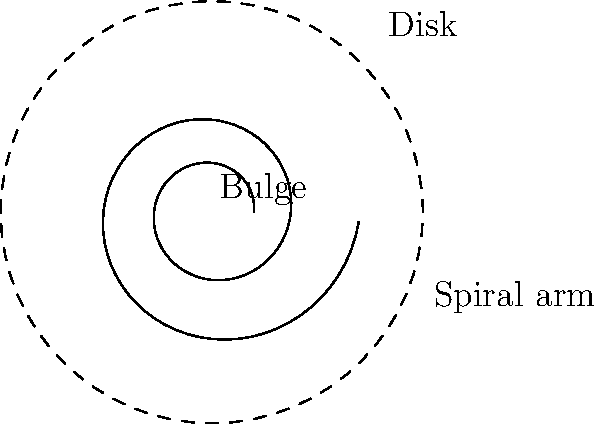As a web developer familiar with creating interactive visualizations, you're tasked with building a dynamic model of a spiral galaxy. Which structural component of the galaxy would you represent using SVG's `<circle>` element, and how does it relate to the galaxy's overall structure? Let's break down the structure of a spiral galaxy and how it relates to web development concepts:

1. Spiral galaxies have three main components:
   a) Bulge: The central, roughly spherical region
   b) Disk: The flat, circular region surrounding the bulge
   c) Spiral arms: The curved structures extending from the disk

2. In the context of web development and SVG:
   a) The bulge can be represented using an SVG `<circle>` element
   b) The disk could be a larger `<circle>` or `<ellipse>`
   c) Spiral arms could be created using `<path>` elements with curved commands

3. The bulge is the most suitable component to represent with a `<circle>` because:
   a) It's approximately spherical in shape
   b) It's centered at the galaxy's core
   c) It has a relatively uniform radius

4. Relationship to overall structure:
   a) The bulge is the central, oldest part of the galaxy
   b) It contains mostly older stars and less gas and dust
   c) Its size relative to the disk can indicate the galaxy's age and type

5. In an interactive model:
   a) The `<circle>` for the bulge could be the base element
   b) Other elements (disk, arms) could be positioned relative to it
   c) Properties like radius could be dynamically adjusted to show different galaxy types

By using an SVG `<circle>` for the bulge, you create a central reference point for building the rest of the galaxy model, mirroring its role in the actual galactic structure.
Answer: The bulge, represented by an SVG `<circle>`, forms the central core of the spiral galaxy. 